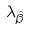Convert formula to latex. <formula><loc_0><loc_0><loc_500><loc_500>\lambda _ { \hat { \beta } }</formula> 